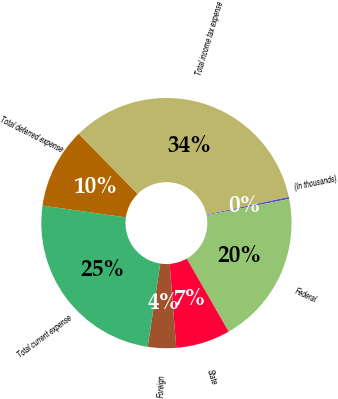<chart> <loc_0><loc_0><loc_500><loc_500><pie_chart><fcel>(In thousands)<fcel>Federal<fcel>State<fcel>Foreign<fcel>Total current expense<fcel>Total deferred expense<fcel>Total income tax expense<nl><fcel>0.28%<fcel>19.8%<fcel>7.03%<fcel>3.65%<fcel>24.84%<fcel>10.4%<fcel>34.0%<nl></chart> 